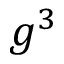<formula> <loc_0><loc_0><loc_500><loc_500>g ^ { 3 }</formula> 